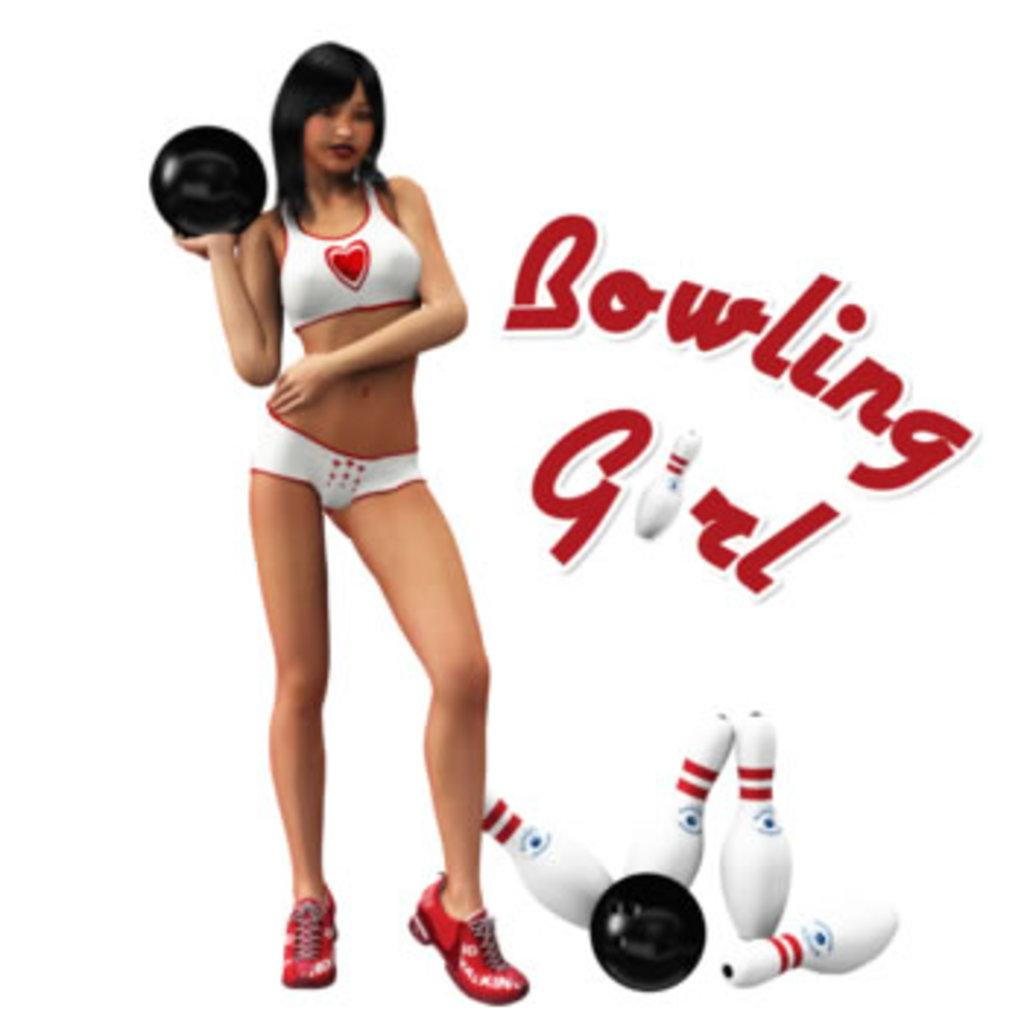<image>
Write a terse but informative summary of the picture. a bowling girl ad that some pins on it 